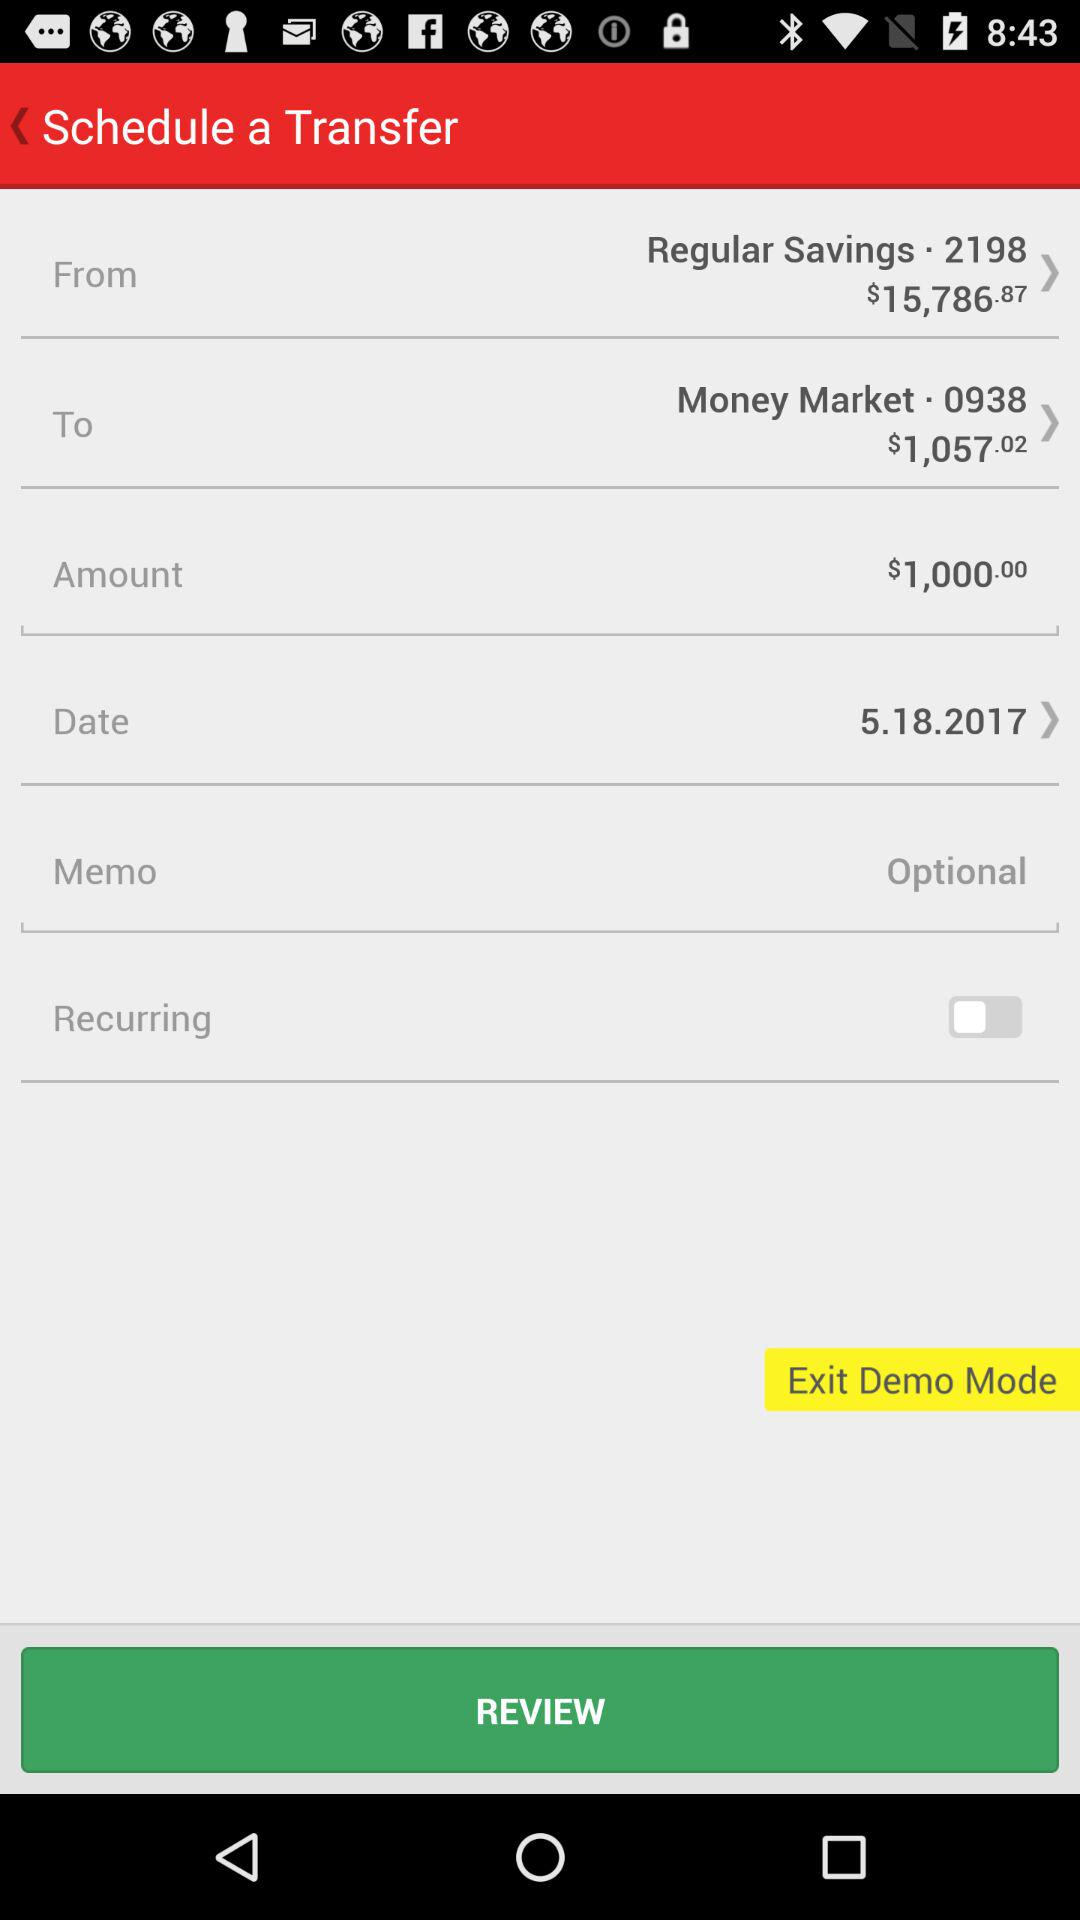How much money is being transferred?
Answer the question using a single word or phrase. $1,000.00 